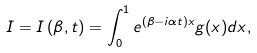<formula> <loc_0><loc_0><loc_500><loc_500>I = I \left ( \beta , t \right ) = \int _ { 0 } ^ { 1 } e ^ { ( \beta - i \alpha t ) x } g ( x ) d x ,</formula> 